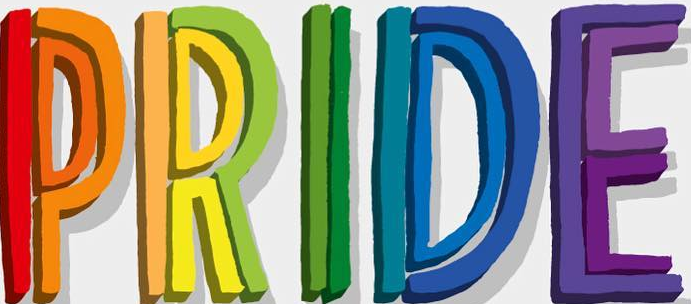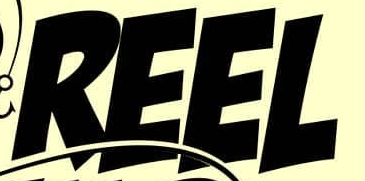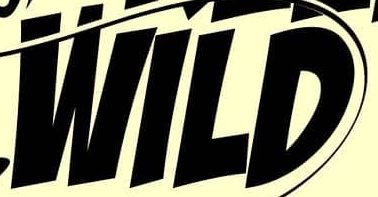Transcribe the words shown in these images in order, separated by a semicolon. PRIDE; REEL; WILD 